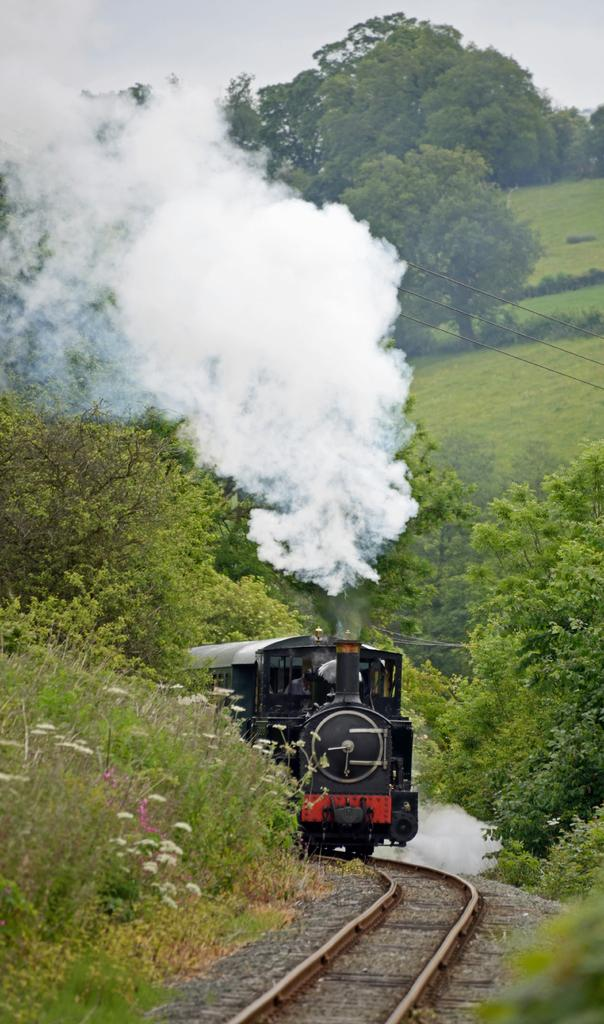What is the color of the train in the image? The train in the image is black. What is the train doing in the image? The train is moving on a track. What is coming out of the train in the image? The train is releasing smoke. What can be seen in the background of the image? There are trees and the sky in the background of the image. What is the condition of the sky in the image? The sky is clear in the image. What type of beef is being cooked on the train in the image? There is no beef or cooking activity present in the image; it features a black color train moving on a track and releasing smoke. 